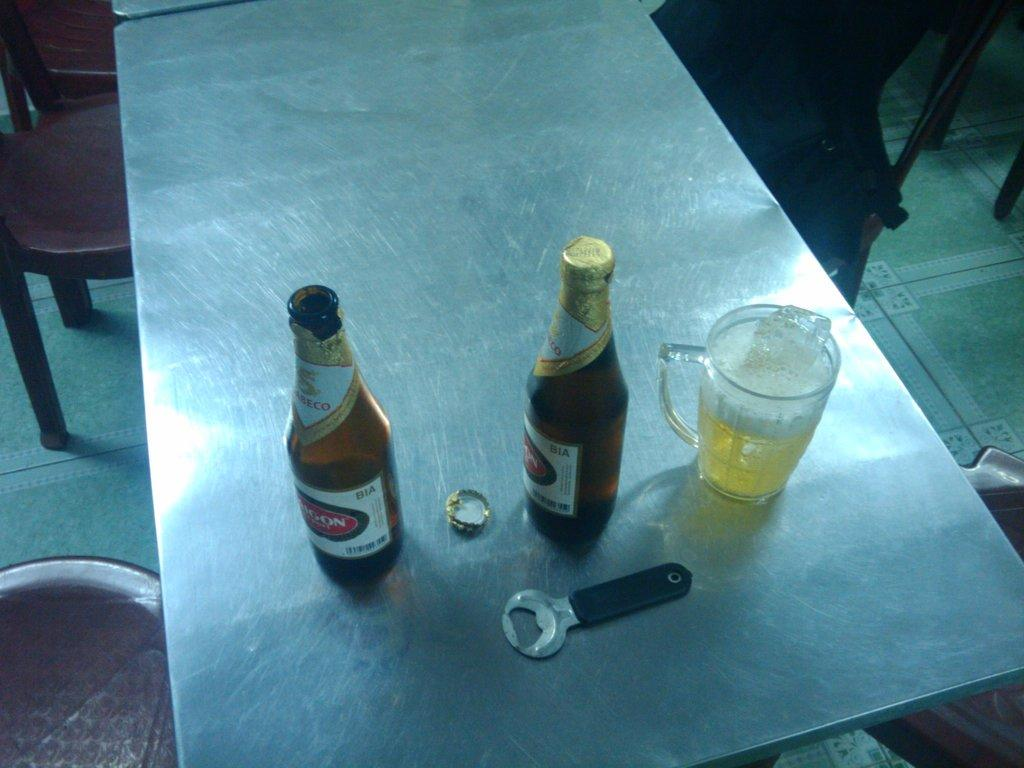What type of table is in the image? There is a steel table in the image. What can be seen on the table? There are two beer bottles, an opener, and a jug of beer on the table. What might be used to open the beer bottles? The opener on the table can be used to open the beer bottles. How many chairs are visible in the image? There are empty chairs in the image. What part of the room can be seen in the image? The floor is visible in the image. What grade is the orange being given in the image? There is no orange present in the image, so it is not possible to determine a grade for an orange. 